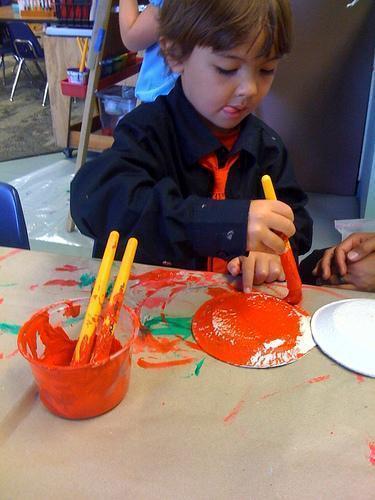Which one of the paint is safe for children art work?
Pick the right solution, then justify: 'Answer: answer
Rationale: rationale.'
Options: Enamel paint, acrylic paint, oil paint, emulsion paint. Answer: acrylic paint.
Rationale: The safest paint for children to use is acrylic paint. 